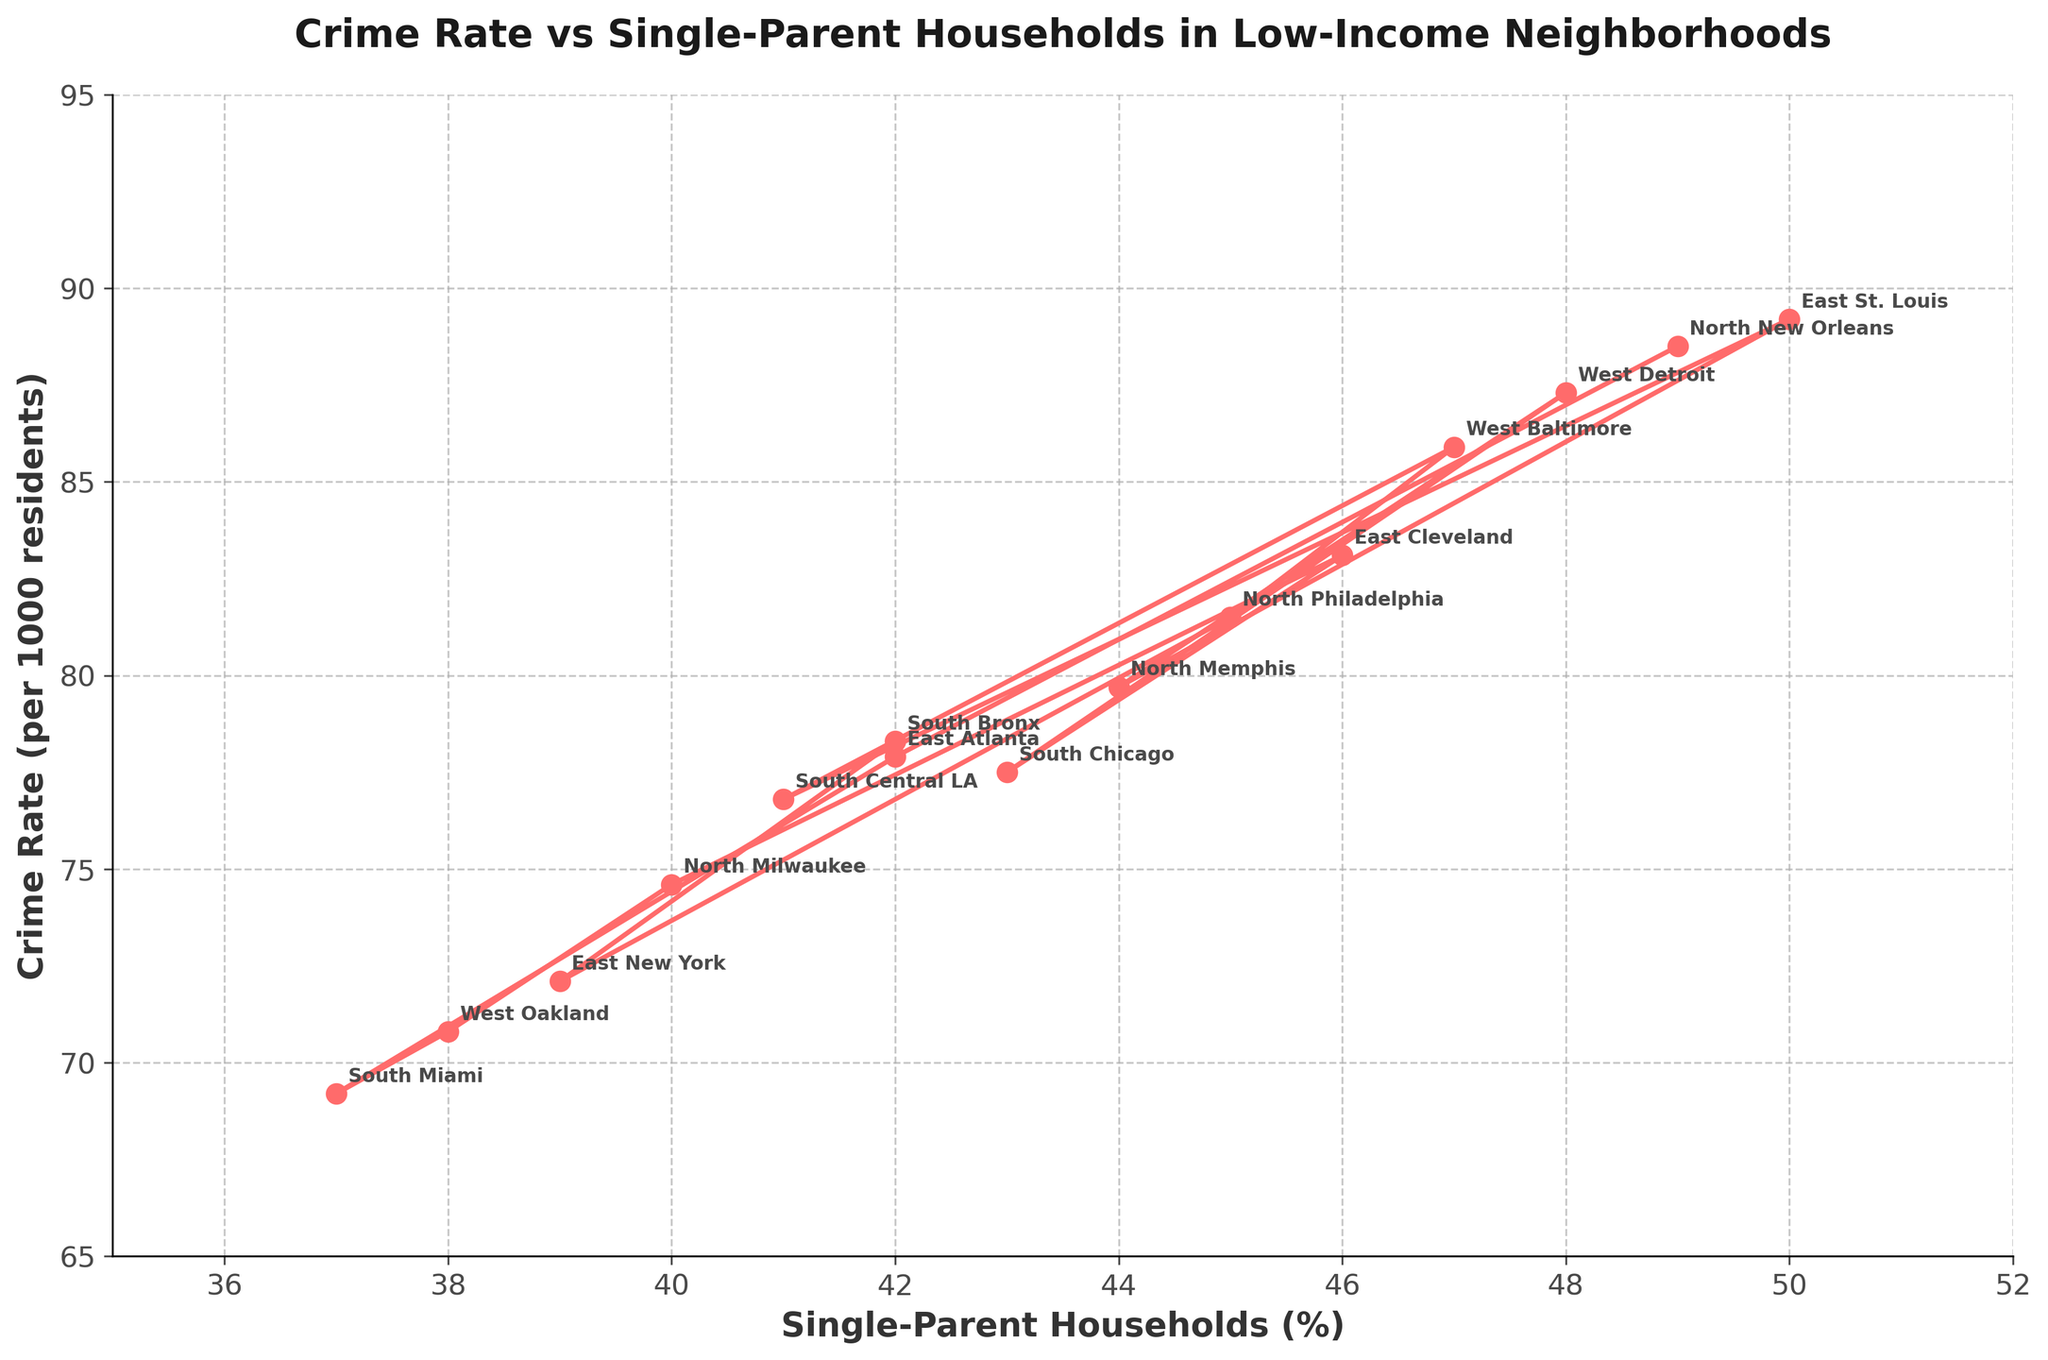What is the neighborhood with the highest single-parent households percentage? By looking at the figure, identify the data point on the x-axis (Single-Parent Households (%)) that is the farthest to the right. The corresponding neighborhood text gives the answer. The highest single-parent percentage is 50%, which corresponds to East St. Louis.
Answer: East St. Louis Which neighborhood has the lowest crime rate? Locate the data point closest to the bottom of the y-axis (Crime Rate per 1000 residents). The corresponding neighborhood text beside this point provides the answer. The lowest crime rate is 69.2, which corresponds to South Miami.
Answer: South Miami Compare the single-parent household percentages between West Detroit and North Memphis; which one is higher? Find the x-coordinates of the data points associated with West Detroit and North Memphis. West Detroit is at 48% and North Memphis is at 44%. Thus, West Detroit is higher.
Answer: West Detroit What is the average crime rate for neighborhoods with more than 45% single-parent households? Identify the data points where the single-parent household percentages are greater than 45%. These are East St. Louis, West Baltimore, North New Orleans, and West Detroit. Sum their crime rates (89.2 + 85.9 + 88.5 + 87.3) = 350.9, and then divide by 4. (350.9 / 4)
Answer: 87.725 Which neighborhood shows both a relatively high crime rate and a lower percentage of single-parent households, compared to others? Look for a data point that is high on the y-axis (Crime Rate) but not far right on the x-axis (Single-Parent Household Percentage). South Bronx has a crime rate of 78.3 with 42% single-parent households. This is relatively high but with a lower single-parent percentage.
Answer: South Bronx By how much does the crime rate in West Baltimore exceed that in South Chicago? Find the y-coordinate (Crime Rate) for both West Baltimore (85.9) and South Chicago (77.5). Subtract the crime rate of South Chicago from that of West Baltimore (85.9 - 77.5).
Answer: 8.4 Which neighborhood marks the closest crime rate to the average crime rate of 80 per 1000 residents? Identify the data point on the y-axis closest to 80. By examining the figure, North Memphis, with 79.7, is closest to 80.
Answer: North Memphis How much higher is the single-parent household percentage in East St. Louis compared to South Miami? Find the x-coordinate (Single-Parent Households) for both East St. Louis (50) and South Miami (37). Subtract the percentage for South Miami from that for East St. Louis (50 - 37).
Answer: 13 Compare the data points visually and identify if there is a general trend between single-parent households percentage and crime rate. Observe the general direction of the data points from left to right. The points trend upwards, indicating that as the percentage of single-parent households increases, the crime rate also increases.
Answer: Positive correlation Which neighborhoods exceed the median value for crime rate among all listed neighborhoods? First, list the crime rates: 78.3, 72.1, 81.5, 85.9, 76.8, 89.2, 79.7, 87.3, 77.5, 83.1, 74.6, 70.8, 69.2, 77.9, 88.5. Order these (69.2, 70.8, 72.1, 74.6, 76.8, 77.5, 77.9, 78.3, 79.7, 81.5, 83.1, 85.9, 87.3, 88.5, 89.2) and find the median (78.3). Neighborhoods above 78.3: North Philadelphia, West Baltimore, East St. Louis, North Memphis, West Detroit, East Cleveland, North New Orleans.
Answer: North Philadelphia, West Baltimore, East St. Louis, North Memphis, West Detroit, East Cleveland, North New Orleans 